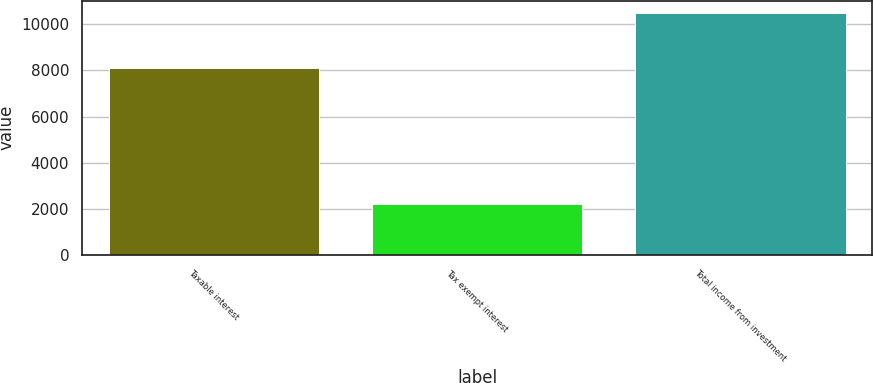<chart> <loc_0><loc_0><loc_500><loc_500><bar_chart><fcel>Taxable interest<fcel>Tax exempt interest<fcel>Total income from investment<nl><fcel>8125<fcel>2197<fcel>10502<nl></chart> 